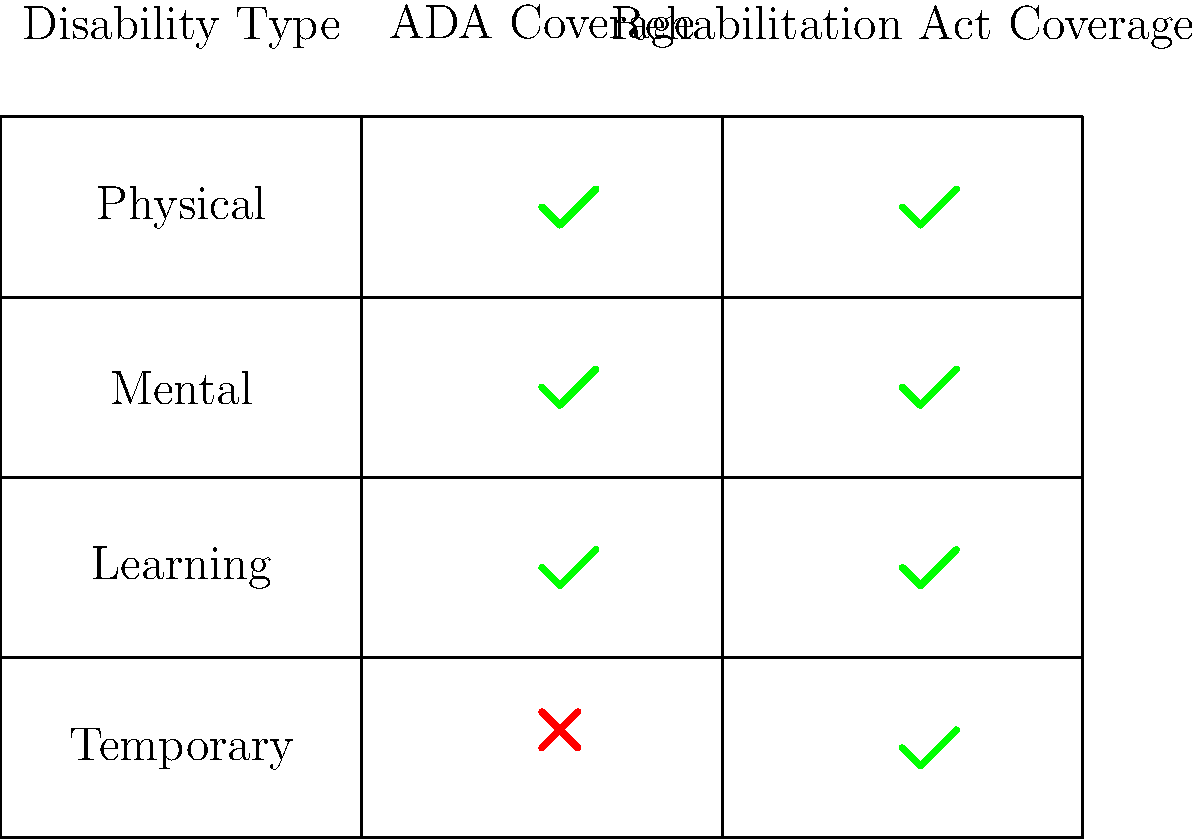Based on the matrix comparing different types of disabilities and their legal protections under the Americans with Disabilities Act (ADA) and the Rehabilitation Act, which type of disability is covered by the Rehabilitation Act but not by the ADA? To answer this question, we need to analyze the matrix provided:

1. The matrix compares four types of disabilities: Physical, Mental, Learning, and Temporary.
2. It shows coverage under two laws: the ADA and the Rehabilitation Act.
3. A green checkmark indicates coverage, while a red cross indicates no coverage.

Let's examine each disability type:

1. Physical Disabilities:
   - ADA: Covered (checkmark)
   - Rehabilitation Act: Covered (checkmark)

2. Mental Disabilities:
   - ADA: Covered (checkmark)
   - Rehabilitation Act: Covered (checkmark)

3. Learning Disabilities:
   - ADA: Covered (checkmark)
   - Rehabilitation Act: Covered (checkmark)

4. Temporary Disabilities:
   - ADA: Not covered (cross)
   - Rehabilitation Act: Covered (checkmark)

From this analysis, we can see that temporary disabilities are the only type that is covered by the Rehabilitation Act but not by the ADA.

This difference in coverage is significant in disability law. The Rehabilitation Act, which predates the ADA, generally has broader coverage in some areas, including temporary disabilities. The ADA, while comprehensive, typically requires a more lasting impact to qualify as a disability.
Answer: Temporary disabilities 